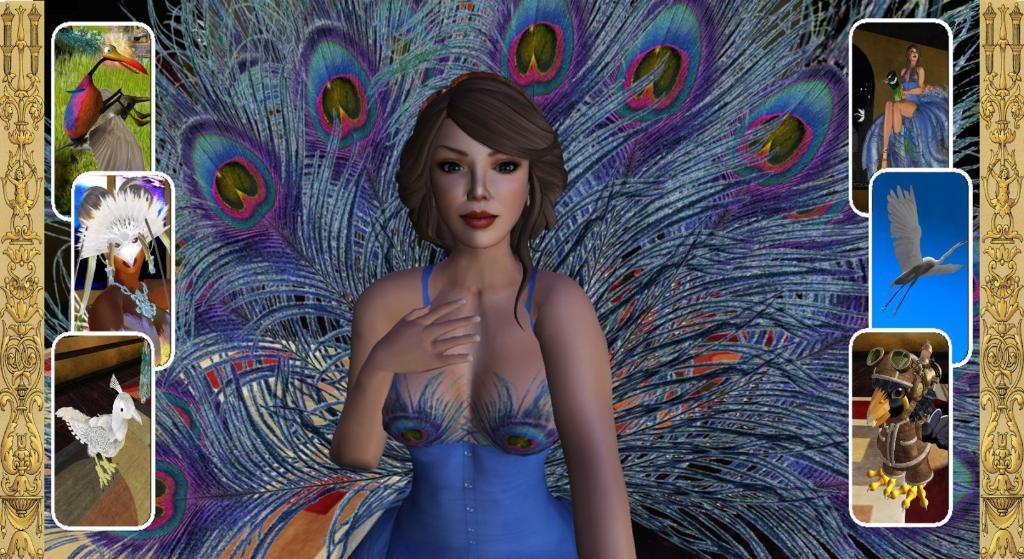How would you summarize this image in a sentence or two? In this image I can see depiction pictures of people and of few animals. 